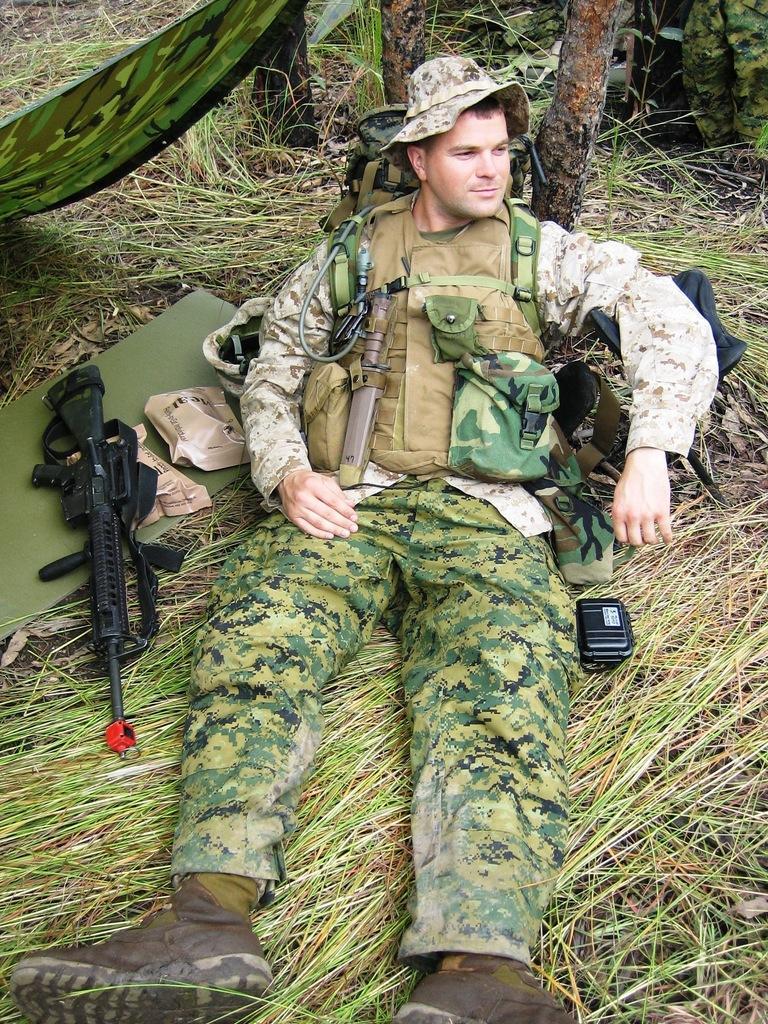How would you summarize this image in a sentence or two? In this image there is a person sitting on the land having grass. He is wearing a cap and a jacket. Left side there is a gun and packets on an object which is on the grassland. Right side there is an object. Right top there are people on the land. Top of the image there are tree trunks. Left top there is a cloth. 